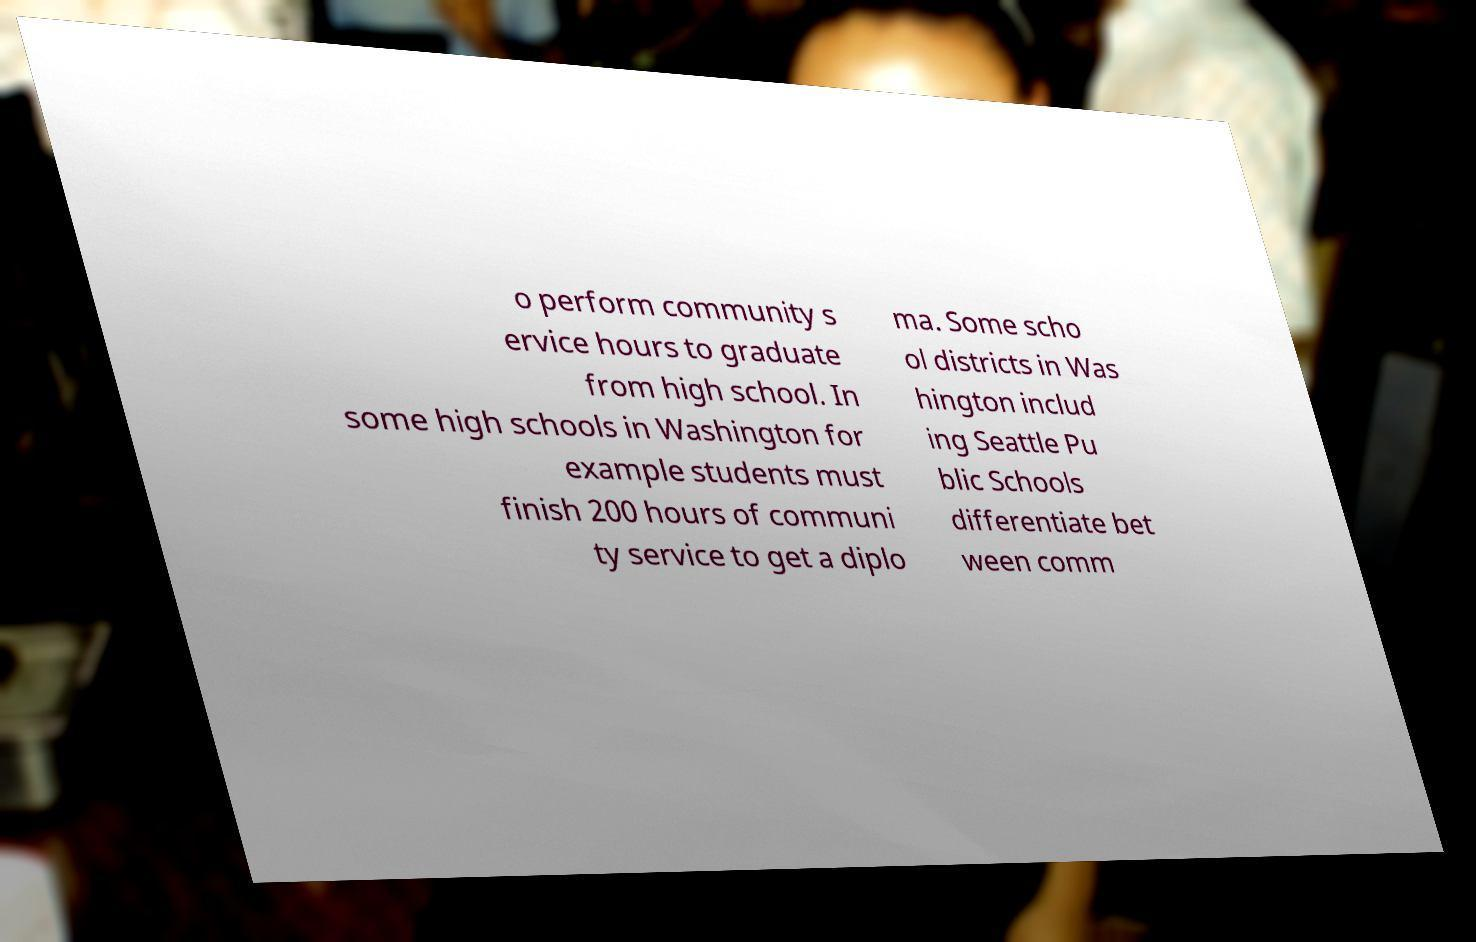Please read and relay the text visible in this image. What does it say? o perform community s ervice hours to graduate from high school. In some high schools in Washington for example students must finish 200 hours of communi ty service to get a diplo ma. Some scho ol districts in Was hington includ ing Seattle Pu blic Schools differentiate bet ween comm 